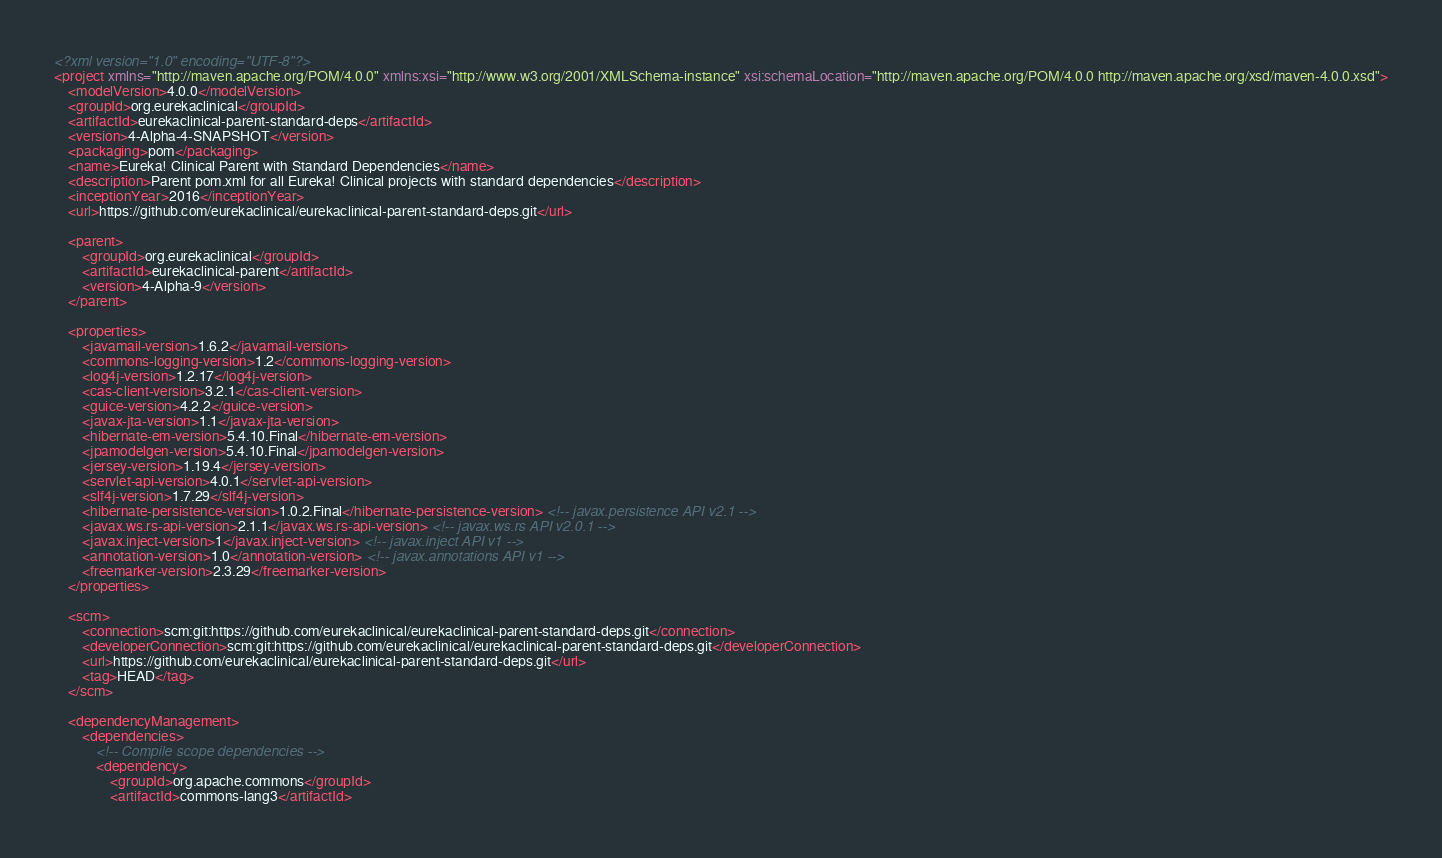<code> <loc_0><loc_0><loc_500><loc_500><_XML_><?xml version="1.0" encoding="UTF-8"?>
<project xmlns="http://maven.apache.org/POM/4.0.0" xmlns:xsi="http://www.w3.org/2001/XMLSchema-instance" xsi:schemaLocation="http://maven.apache.org/POM/4.0.0 http://maven.apache.org/xsd/maven-4.0.0.xsd">
    <modelVersion>4.0.0</modelVersion>
    <groupId>org.eurekaclinical</groupId>
    <artifactId>eurekaclinical-parent-standard-deps</artifactId>
    <version>4-Alpha-4-SNAPSHOT</version>
    <packaging>pom</packaging>
    <name>Eureka! Clinical Parent with Standard Dependencies</name>
    <description>Parent pom.xml for all Eureka! Clinical projects with standard dependencies</description>
    <inceptionYear>2016</inceptionYear>
    <url>https://github.com/eurekaclinical/eurekaclinical-parent-standard-deps.git</url>

    <parent>
        <groupId>org.eurekaclinical</groupId>
        <artifactId>eurekaclinical-parent</artifactId>
        <version>4-Alpha-9</version>
    </parent>

    <properties>
        <javamail-version>1.6.2</javamail-version>
        <commons-logging-version>1.2</commons-logging-version>
        <log4j-version>1.2.17</log4j-version>
        <cas-client-version>3.2.1</cas-client-version>
        <guice-version>4.2.2</guice-version>
        <javax-jta-version>1.1</javax-jta-version>
        <hibernate-em-version>5.4.10.Final</hibernate-em-version>
        <jpamodelgen-version>5.4.10.Final</jpamodelgen-version>
        <jersey-version>1.19.4</jersey-version>
        <servlet-api-version>4.0.1</servlet-api-version>
        <slf4j-version>1.7.29</slf4j-version>
        <hibernate-persistence-version>1.0.2.Final</hibernate-persistence-version> <!-- javax.persistence API v2.1 -->
        <javax.ws.rs-api-version>2.1.1</javax.ws.rs-api-version> <!-- javax.ws.rs API v2.0.1 -->
        <javax.inject-version>1</javax.inject-version> <!-- javax.inject API v1 -->
        <annotation-version>1.0</annotation-version> <!-- javax.annotations API v1 -->
        <freemarker-version>2.3.29</freemarker-version>
    </properties>

    <scm>
        <connection>scm:git:https://github.com/eurekaclinical/eurekaclinical-parent-standard-deps.git</connection>
        <developerConnection>scm:git:https://github.com/eurekaclinical/eurekaclinical-parent-standard-deps.git</developerConnection>
        <url>https://github.com/eurekaclinical/eurekaclinical-parent-standard-deps.git</url>
        <tag>HEAD</tag>
    </scm>

    <dependencyManagement>
        <dependencies>
            <!-- Compile scope dependencies -->
            <dependency>
                <groupId>org.apache.commons</groupId>
                <artifactId>commons-lang3</artifactId></code> 